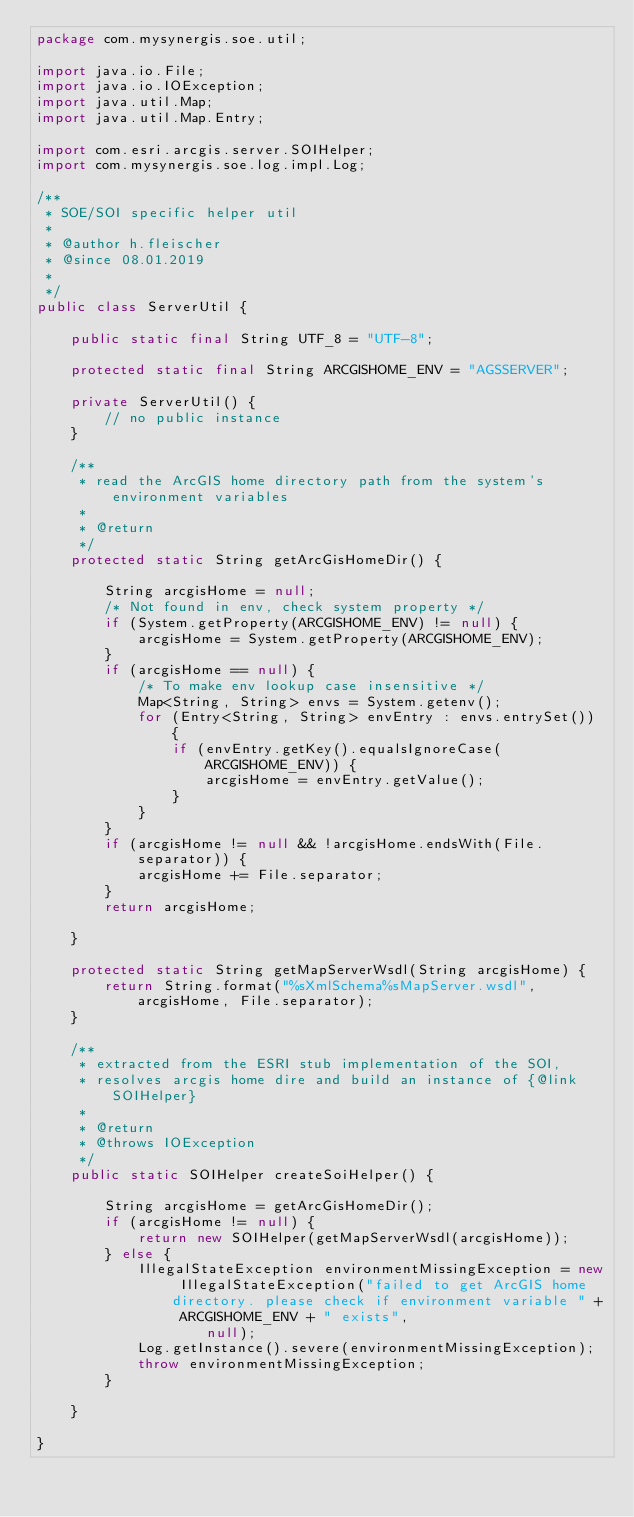<code> <loc_0><loc_0><loc_500><loc_500><_Java_>package com.mysynergis.soe.util;

import java.io.File;
import java.io.IOException;
import java.util.Map;
import java.util.Map.Entry;

import com.esri.arcgis.server.SOIHelper;
import com.mysynergis.soe.log.impl.Log;

/**
 * SOE/SOI specific helper util
 *
 * @author h.fleischer
 * @since 08.01.2019
 *
 */
public class ServerUtil {

    public static final String UTF_8 = "UTF-8";

    protected static final String ARCGISHOME_ENV = "AGSSERVER";

    private ServerUtil() {
        // no public instance
    }

    /**
     * read the ArcGIS home directory path from the system's environment variables
     *
     * @return
     */
    protected static String getArcGisHomeDir() {

        String arcgisHome = null;
        /* Not found in env, check system property */
        if (System.getProperty(ARCGISHOME_ENV) != null) {
            arcgisHome = System.getProperty(ARCGISHOME_ENV);
        }
        if (arcgisHome == null) {
            /* To make env lookup case insensitive */
            Map<String, String> envs = System.getenv();
            for (Entry<String, String> envEntry : envs.entrySet()) {
                if (envEntry.getKey().equalsIgnoreCase(ARCGISHOME_ENV)) {
                    arcgisHome = envEntry.getValue();
                }
            }
        }
        if (arcgisHome != null && !arcgisHome.endsWith(File.separator)) {
            arcgisHome += File.separator;
        }
        return arcgisHome;

    }

    protected static String getMapServerWsdl(String arcgisHome) {
        return String.format("%sXmlSchema%sMapServer.wsdl", arcgisHome, File.separator);
    }

    /**
     * extracted from the ESRI stub implementation of the SOI,
     * resolves arcgis home dire and build an instance of {@link SOIHelper}
     *
     * @return
     * @throws IOException
     */
    public static SOIHelper createSoiHelper() {

        String arcgisHome = getArcGisHomeDir();
        if (arcgisHome != null) {
            return new SOIHelper(getMapServerWsdl(arcgisHome));
        } else {
            IllegalStateException environmentMissingException = new IllegalStateException("failed to get ArcGIS home directory. please check if environment variable " + ARCGISHOME_ENV + " exists",
                    null);
            Log.getInstance().severe(environmentMissingException);
            throw environmentMissingException;
        }

    }

}
</code> 